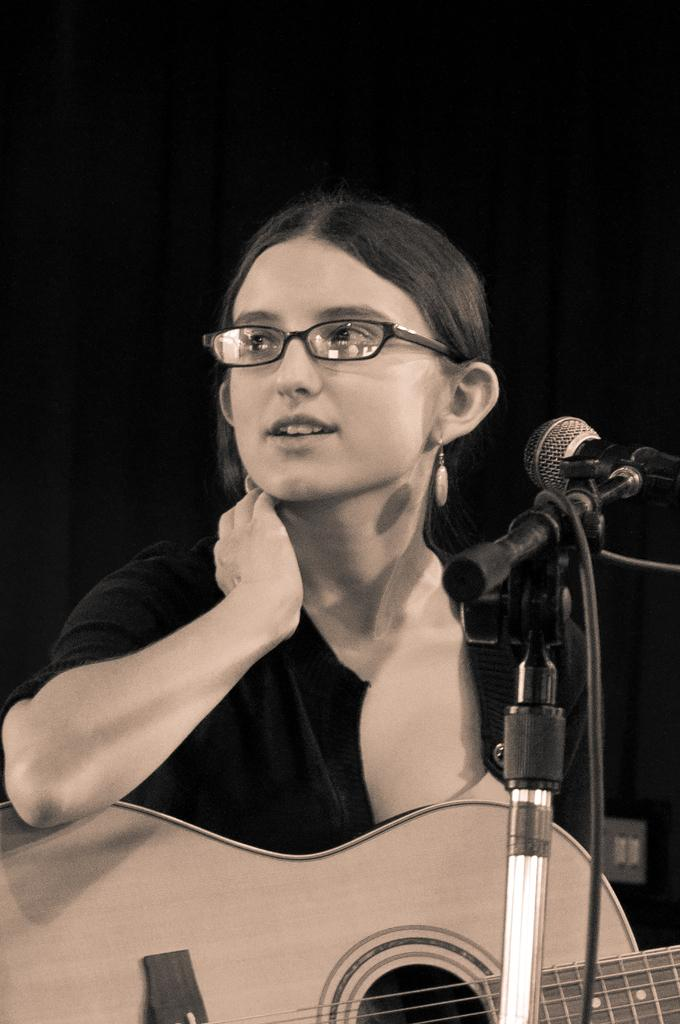What is the gender of the person in the image? The person in the image is a lady. What is the lady person wearing in the image? The lady person is wearing a black dress and spectacles. What activity is the lady person engaged in? The lady person is playing a guitar. What object is in front of the lady person? There is a microphone in front of the lady person. Can you see any signs of an argument between the lady person and the structure in the image? There is no structure present in the image, and no signs of an argument can be observed. How many toes does the lady person have in the image? The image does not show the lady person's toes, so it cannot be determined from the image. 